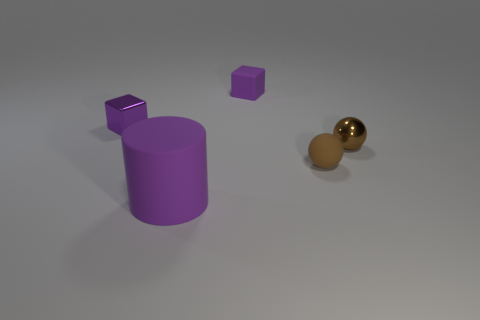Are there any other things that are the same size as the purple cylinder?
Your answer should be compact. No. There is a cylinder that is the same color as the tiny rubber cube; what is its material?
Give a very brief answer. Rubber. Are there more purple metallic cubes than brown cylinders?
Give a very brief answer. Yes. What is the shape of the purple rubber thing that is to the left of the purple rubber block behind the purple block on the left side of the large purple matte cylinder?
Your answer should be very brief. Cylinder. Is the number of large matte objects on the right side of the tiny matte block less than the number of small brown objects that are to the right of the cylinder?
Provide a short and direct response. Yes. Is there a small rubber cube of the same color as the matte sphere?
Provide a short and direct response. No. Is the material of the purple cylinder the same as the thing behind the purple metallic thing?
Provide a short and direct response. Yes. Is there a matte block behind the small cube to the right of the purple metal cube?
Make the answer very short. No. What is the color of the rubber thing that is both in front of the tiny purple metal object and behind the large purple matte cylinder?
Your answer should be compact. Brown. How big is the cylinder?
Ensure brevity in your answer.  Large. 